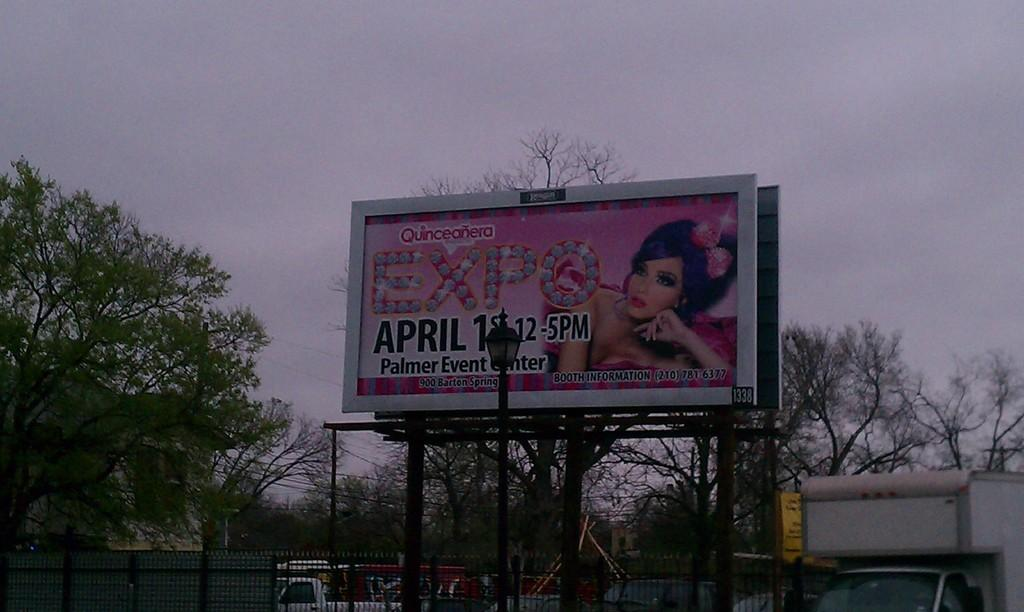Provide a one-sentence caption for the provided image. A roadside sign advertises an Expo at the Palmer Event Center. 